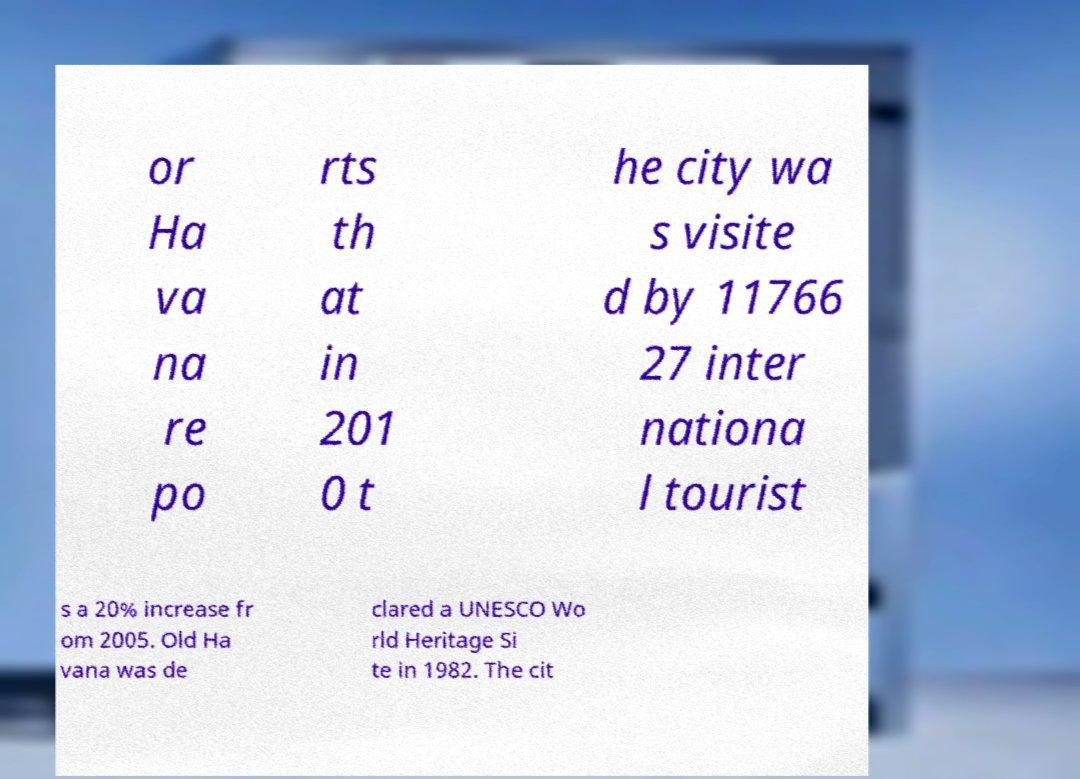Can you accurately transcribe the text from the provided image for me? or Ha va na re po rts th at in 201 0 t he city wa s visite d by 11766 27 inter nationa l tourist s a 20% increase fr om 2005. Old Ha vana was de clared a UNESCO Wo rld Heritage Si te in 1982. The cit 